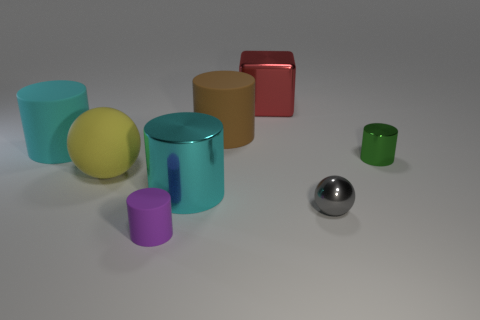How many rubber objects are the same color as the large shiny cylinder?
Your answer should be compact. 1. Is the number of cyan metallic objects left of the big yellow thing less than the number of large things that are in front of the small green cylinder?
Provide a succinct answer. Yes. Is there a red cube that has the same size as the gray object?
Keep it short and to the point. No. Does the cyan cylinder that is right of the purple rubber cylinder have the same size as the cyan matte cylinder?
Your answer should be compact. Yes. Are there more large brown rubber cylinders than big rubber things?
Your answer should be very brief. No. Is there a tiny green object that has the same shape as the yellow object?
Keep it short and to the point. No. What shape is the metal object that is on the left side of the metal cube?
Your answer should be very brief. Cylinder. There is a large cyan cylinder behind the big shiny object on the left side of the brown cylinder; how many small rubber cylinders are to the right of it?
Offer a very short reply. 1. Does the thing to the left of the large yellow object have the same color as the big shiny cylinder?
Provide a short and direct response. Yes. How many other objects are there of the same shape as the large brown object?
Offer a very short reply. 4. 